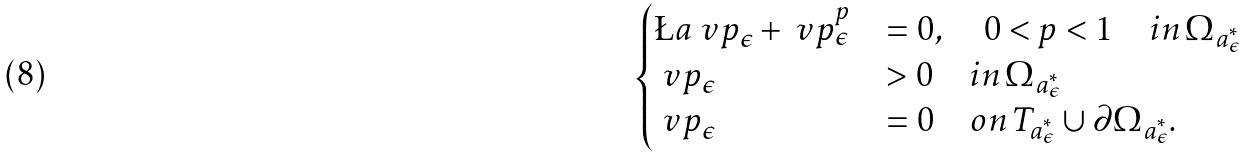Convert formula to latex. <formula><loc_0><loc_0><loc_500><loc_500>\begin{cases} \L a \ v p _ { \epsilon } + \ v p ^ { p } _ { \epsilon } & = 0 , \quad 0 < p < 1 \quad i n \, \Omega _ { a ^ { \ast } _ { \epsilon } } \\ \ v p _ { \epsilon } & > 0 \quad i n \, \Omega _ { a ^ { \ast } _ { \epsilon } } \\ \ v p _ { \epsilon } & = 0 \quad o n \, T _ { a ^ { \ast } _ { \epsilon } } \cup \partial \Omega _ { a ^ { \ast } _ { \epsilon } } . \end{cases}</formula> 